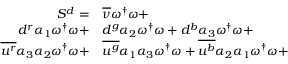Convert formula to latex. <formula><loc_0><loc_0><loc_500><loc_500>\begin{array} { r l } { S ^ { d } = } & { \overline { \nu } } \omega ^ { \dagger } \omega + } \\ { { d } ^ { r } { \alpha _ { 1 } } \omega ^ { \dagger } \omega + } & { d } ^ { g } { \alpha _ { 2 } } \omega ^ { \dagger } \omega + { d } ^ { b } { \alpha _ { 3 } } \omega ^ { \dagger } \omega + } \\ { \overline { { u ^ { r } } } { \alpha _ { 3 } } { \alpha _ { 2 } } \omega ^ { \dagger } \omega + } & \overline { { u ^ { g } } } { \alpha _ { 1 } } { \alpha _ { 3 } } \omega ^ { \dagger } \omega + \overline { { u ^ { b } } } { \alpha _ { 2 } } { \alpha _ { 1 } } \omega ^ { \dagger } \omega + } \end{array}</formula> 